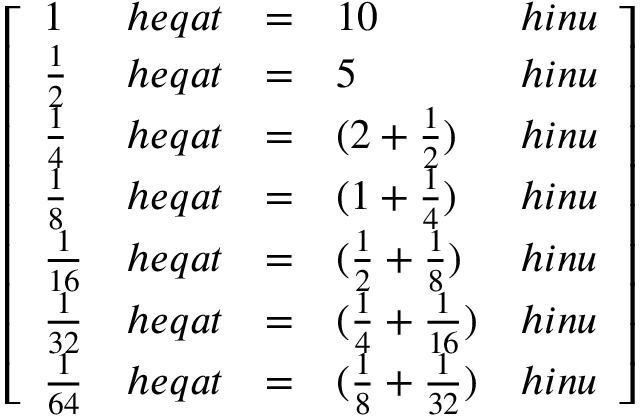Convert formula to latex. <formula><loc_0><loc_0><loc_500><loc_500>{ \left [ \begin{array} { l l l l l } { 1 } & { h e q a t } & { = } & { 1 0 } & { h i n u } \\ { { \frac { 1 } { 2 } } } & { h e q a t } & { = } & { 5 } & { h i n u } \\ { { \frac { 1 } { 4 } } } & { h e q a t } & { = } & { ( 2 + { \frac { 1 } { 2 } } ) } & { h i n u } \\ { { \frac { 1 } { 8 } } } & { h e q a t } & { = } & { ( 1 + { \frac { 1 } { 4 } } ) } & { h i n u } \\ { { \frac { 1 } { 1 6 } } } & { h e q a t } & { = } & { ( { \frac { 1 } { 2 } } + { \frac { 1 } { 8 } } ) } & { h i n u } \\ { { \frac { 1 } { 3 2 } } } & { h e q a t } & { = } & { ( { \frac { 1 } { 4 } } + { \frac { 1 } { 1 6 } } ) } & { h i n u } \\ { { \frac { 1 } { 6 4 } } } & { h e q a t } & { = } & { ( { \frac { 1 } { 8 } } + { \frac { 1 } { 3 2 } } ) } & { h i n u } \end{array} \right ] }</formula> 